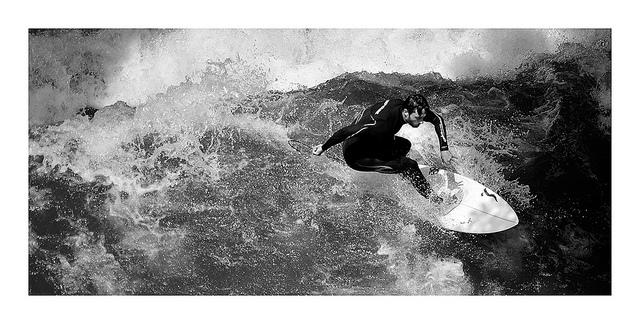Is there anyone on the boat?
Quick response, please. No. What is he doing?
Concise answer only. Surfing. Is the water calm?
Concise answer only. No. 